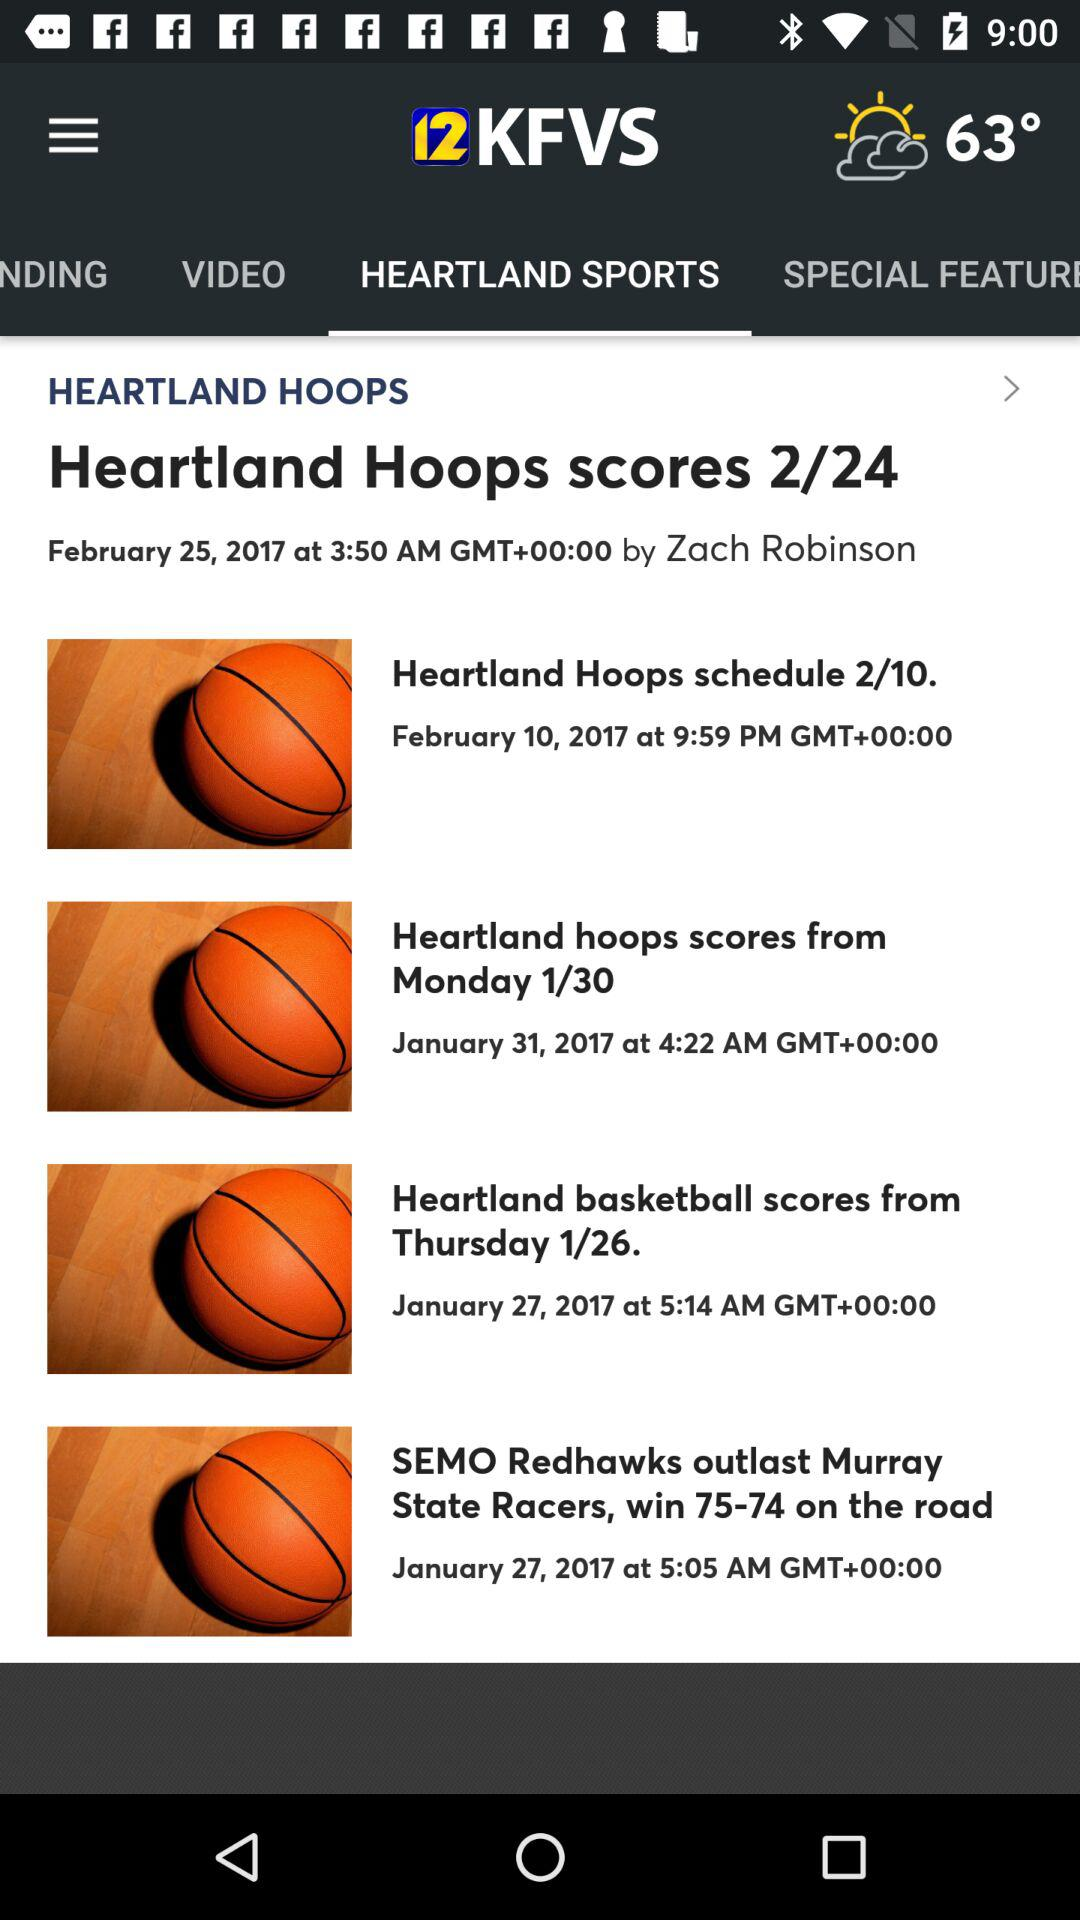What is the temperature? The temperature is 63°. 